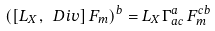<formula> <loc_0><loc_0><loc_500><loc_500>\left ( \left [ L _ { X } , \ D i v \right ] F _ { m } \right ) ^ { b } = L _ { X } \Gamma ^ { a } _ { a c } \, F ^ { c b } _ { m }</formula> 